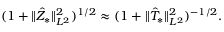<formula> <loc_0><loc_0><loc_500><loc_500>( 1 + \| \hat { Z } _ { * } \| _ { L ^ { 2 } } ^ { 2 } ) ^ { 1 / 2 } \approx ( 1 + \| \hat { T } _ { * } \| _ { L ^ { 2 } } ^ { 2 } ) ^ { - 1 / 2 } .</formula> 